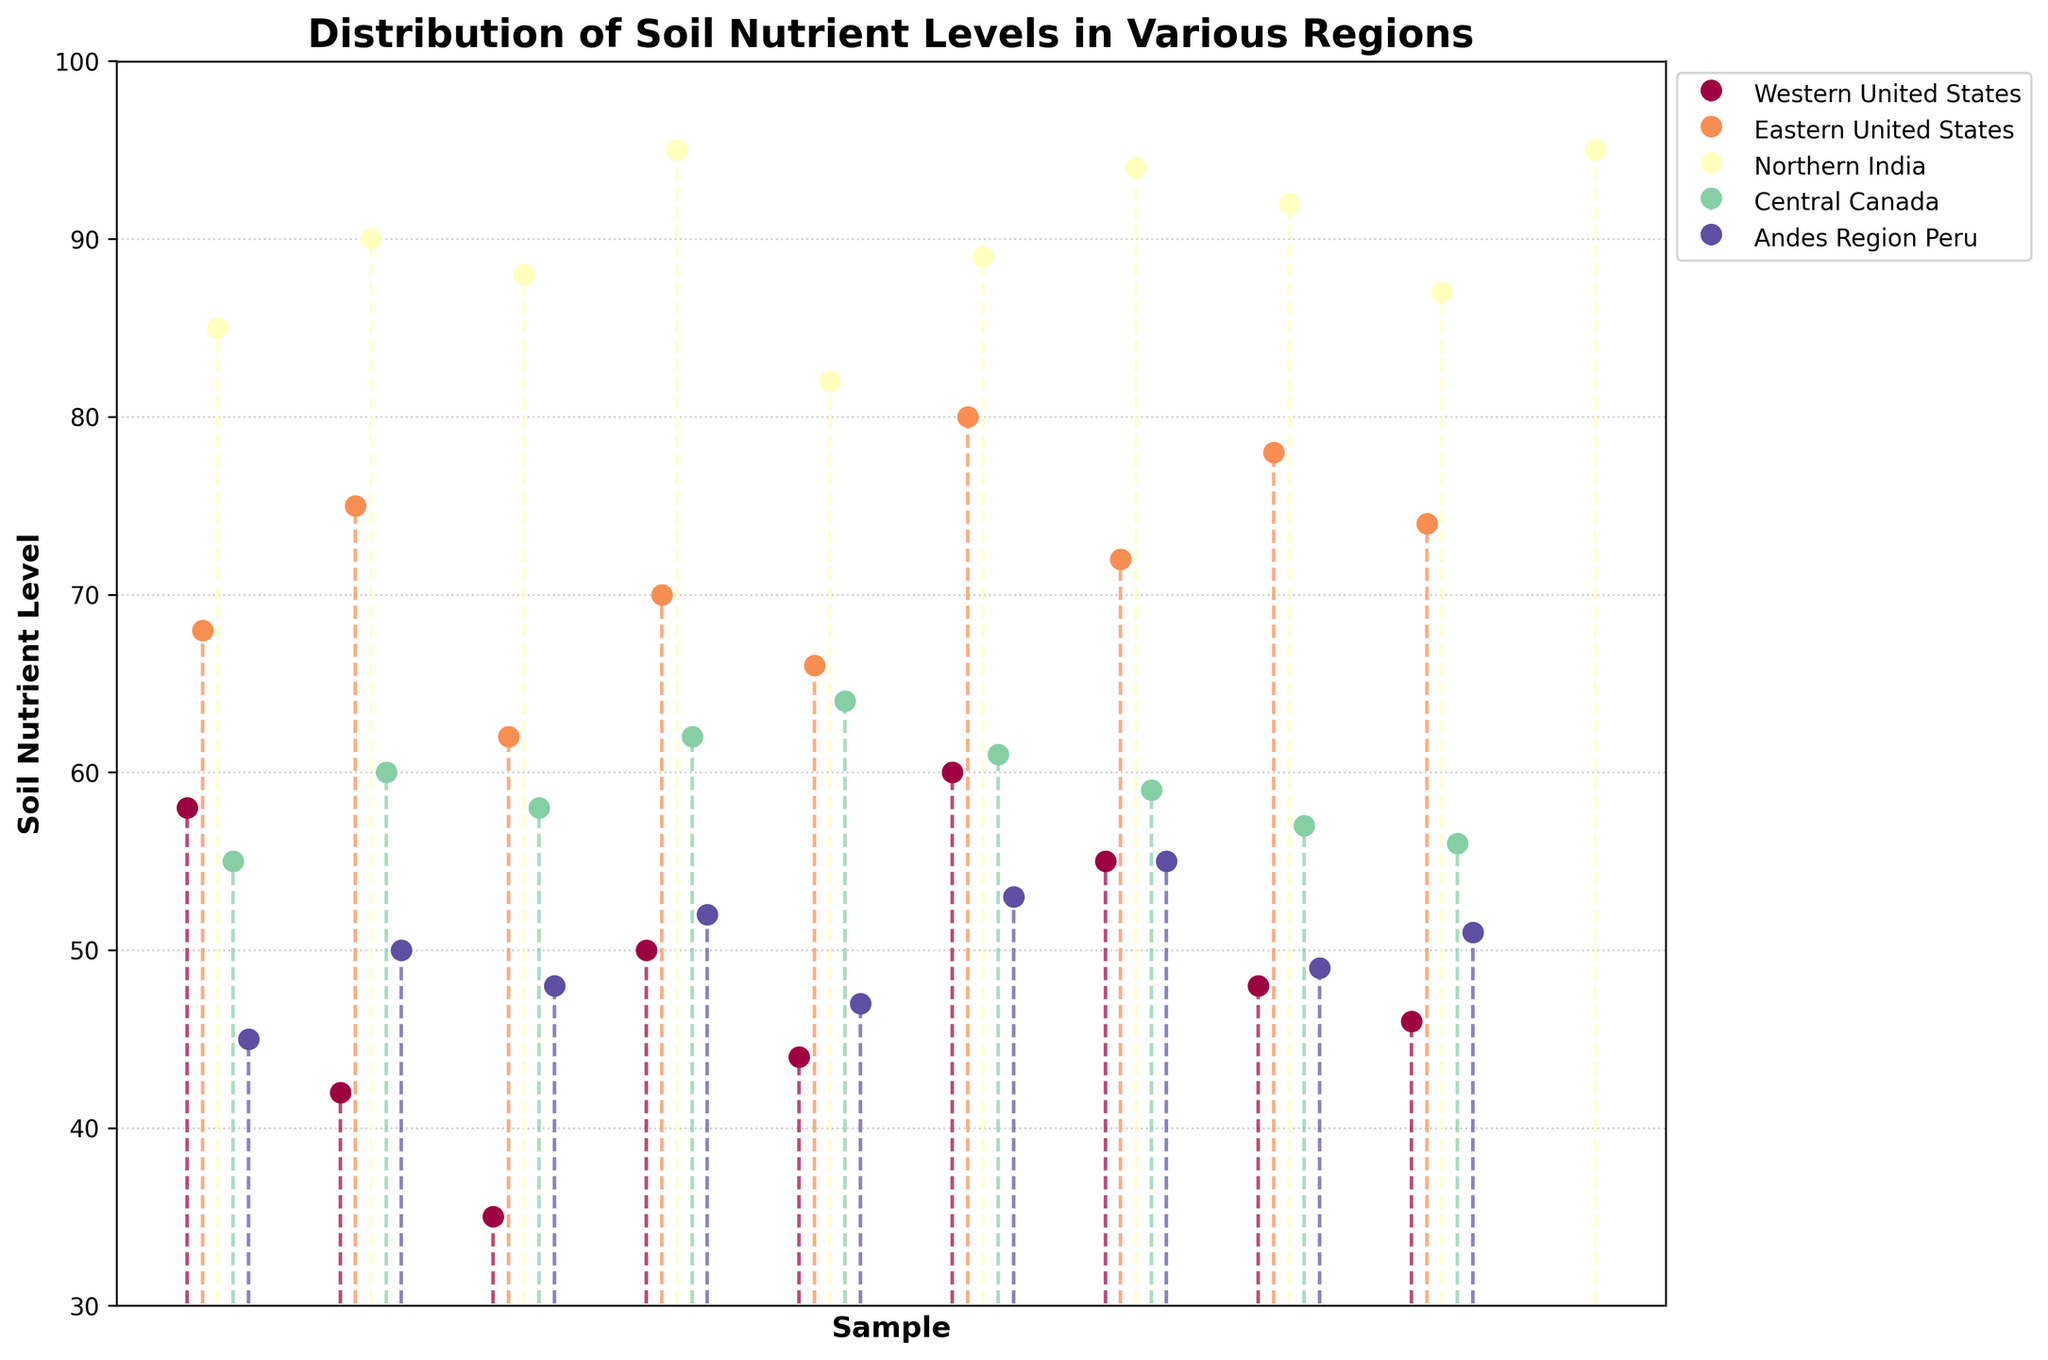What is the title of the plot? The title is usually displayed at the top of the plot to describe what the figure is about.
Answer: Distribution of Soil Nutrient Levels in Various Regions What is the highest soil nutrient level recorded in the Eastern United States? By looking at the markers for the Eastern United States, the highest marker value can be found.
Answer: 80 Which region has the most varied range of soil nutrient levels? By scanning through the different regions and comparing their ranges (difference between highest and lowest values), Northern India shows the widest range from 82 to 95.
Answer: Northern India What is the average soil nutrient level for the Andes Region, Peru? The nutrient levels are 45, 50, 48, 52, 47, 53, 55, 49, and 51. Summing these gives 400, and dividing by 9 gives approximately 44.44.
Answer: 50 In the Western United States, what is the difference between the highest and lowest nutrient levels? The highest value is 60, and the lowest is 35, so the difference is 60 - 35 = 25.
Answer: 25 Which region recorded a nutrient level of 95? By looking at the markers with the highest nutrient levels, Northern India has two markers that reach 95.
Answer: Northern India What is the median soil nutrient level for Central Canada? Sorting the nutrient levels (55, 60, 58, 62, 64, 61, 59, 57, 56) and finding the middle value: 58.
Answer: 58 Compare the average soil nutrient levels of Western United States and Eastern United States. Which one is higher and by how much? Calculate the average for Western U.S. (Standard Sum: 438/9 = 48.67) and Eastern U.S. (Sum: 575/9 = 63.89). The Eastern U.S. average is higher by 15.22.
Answer: Eastern United States by 15.22 Which region appears to have the least fluctuation in soil nutrient levels based on the plot? By inspecting the plot visually, Central Canada shows the least fluctuation with values close to each other.
Answer: Central Canada 